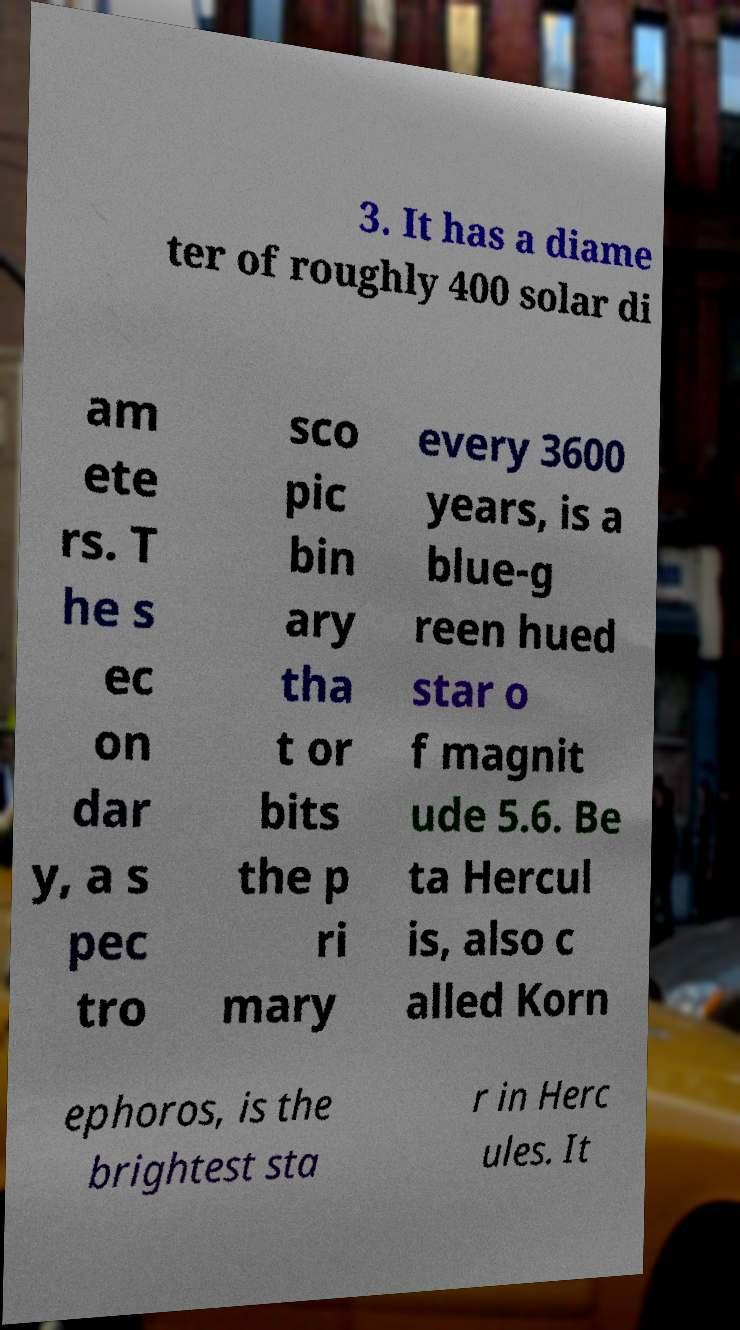Please identify and transcribe the text found in this image. 3. It has a diame ter of roughly 400 solar di am ete rs. T he s ec on dar y, a s pec tro sco pic bin ary tha t or bits the p ri mary every 3600 years, is a blue-g reen hued star o f magnit ude 5.6. Be ta Hercul is, also c alled Korn ephoros, is the brightest sta r in Herc ules. It 